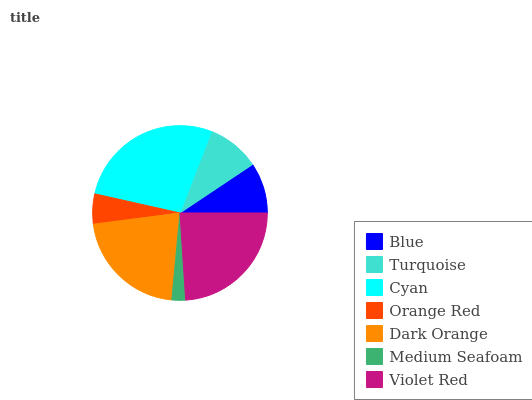Is Medium Seafoam the minimum?
Answer yes or no. Yes. Is Cyan the maximum?
Answer yes or no. Yes. Is Turquoise the minimum?
Answer yes or no. No. Is Turquoise the maximum?
Answer yes or no. No. Is Turquoise greater than Blue?
Answer yes or no. Yes. Is Blue less than Turquoise?
Answer yes or no. Yes. Is Blue greater than Turquoise?
Answer yes or no. No. Is Turquoise less than Blue?
Answer yes or no. No. Is Turquoise the high median?
Answer yes or no. Yes. Is Turquoise the low median?
Answer yes or no. Yes. Is Blue the high median?
Answer yes or no. No. Is Medium Seafoam the low median?
Answer yes or no. No. 